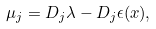<formula> <loc_0><loc_0><loc_500><loc_500>\mu _ { j } = D _ { j } \lambda - D _ { j } \epsilon ( x ) ,</formula> 